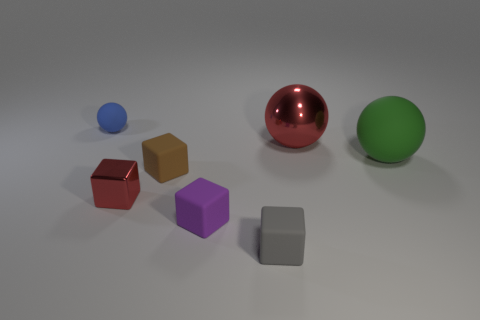Add 1 tiny matte blocks. How many objects exist? 8 Subtract all metal spheres. How many spheres are left? 2 Subtract all red balls. How many balls are left? 2 Subtract all blocks. How many objects are left? 3 Subtract all blue cylinders. How many yellow balls are left? 0 Subtract all purple rubber objects. Subtract all gray rubber objects. How many objects are left? 5 Add 3 green matte things. How many green matte things are left? 4 Add 1 cyan objects. How many cyan objects exist? 1 Subtract 1 purple blocks. How many objects are left? 6 Subtract 2 cubes. How many cubes are left? 2 